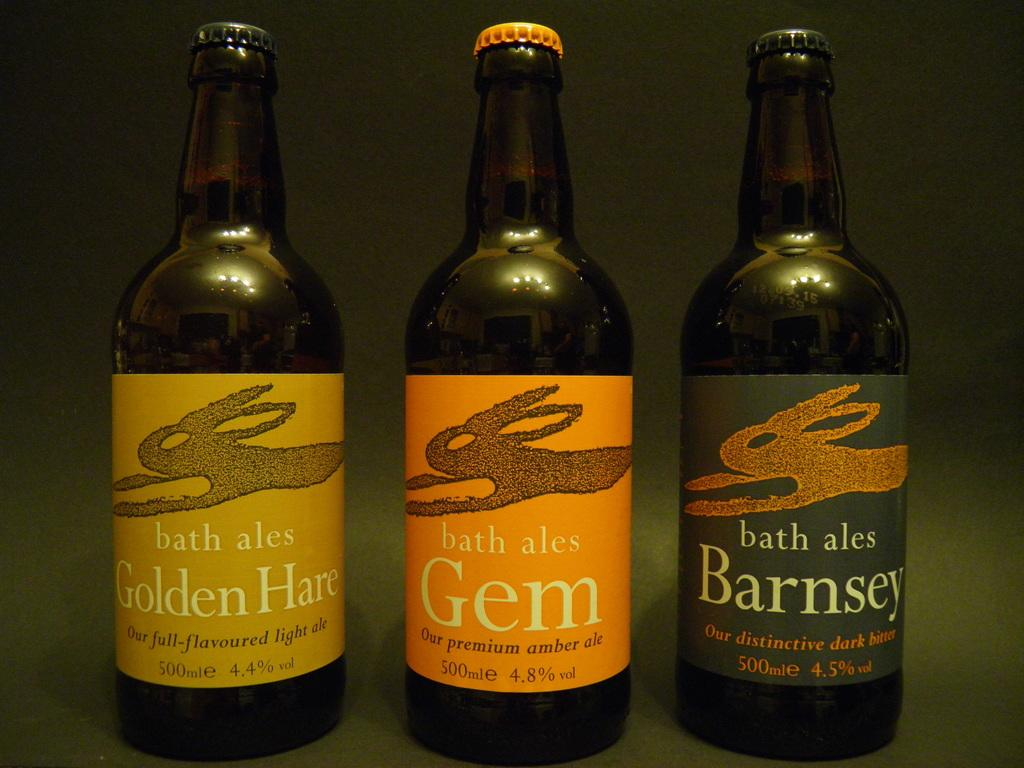<image>
Present a compact description of the photo's key features. Three beers from Bath Ales, one called Golden Hare, the other Gem, and the third Barnsey. 